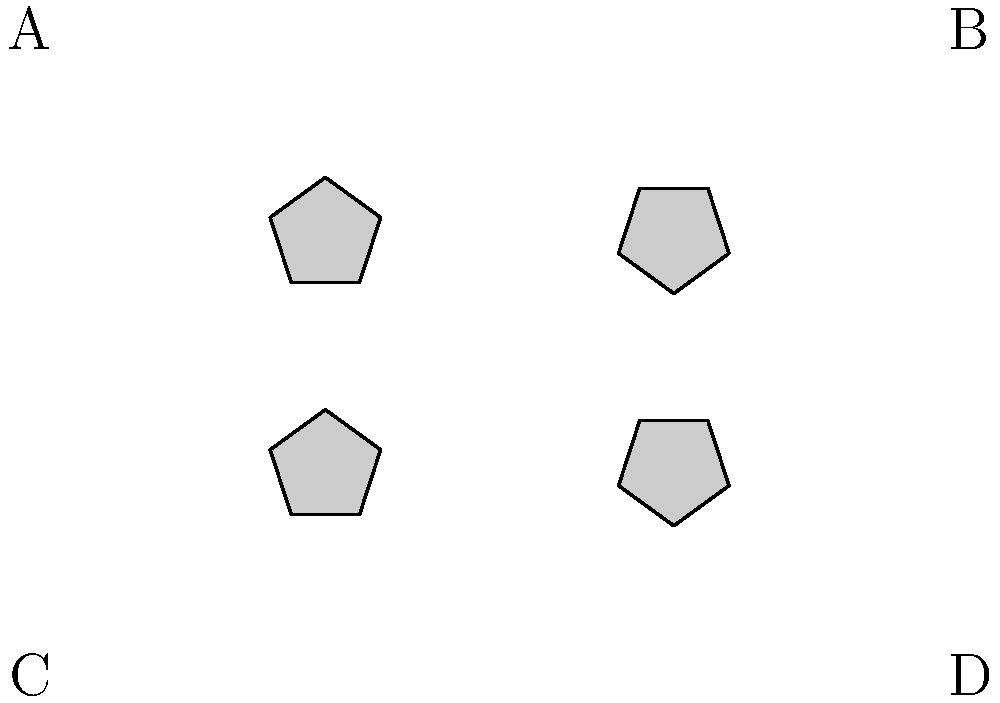Consider the four pentagons labeled A, B, C, and D. Which pair of pentagons are identical when one is rotated to match the other? To solve this problem, we need to mentally rotate each pentagon and compare it with the others. Let's analyze each pair step-by-step:

1. Compare A and B:
   - A is a regular pentagon in its standard orientation.
   - B appears to be rotated clockwise by 36° (one-tenth of a full rotation).
   - If we rotate A clockwise by 36°, it would match B.

2. Compare A and C:
   - C appears to be rotated clockwise by 72° (one-fifth of a full rotation).
   - If we rotate A clockwise by 72°, it would not match C.

3. Compare A and D:
   - D appears to be rotated counterclockwise by 36°.
   - If we rotate A counterclockwise by 36°, it would not match D.

4. Compare B and C:
   - B is rotated 36° clockwise from the standard orientation.
   - C is rotated 72° clockwise from the standard orientation.
   - The difference in rotation is 36°, so they do not match.

5. Compare B and D:
   - B is rotated 36° clockwise from the standard orientation.
   - D is rotated 36° counterclockwise from the standard orientation.
   - The total difference in rotation is 72°, so they do not match.

6. Compare C and D:
   - C is rotated 72° clockwise from the standard orientation.
   - D is rotated 36° counterclockwise from the standard orientation.
   - The total difference in rotation is 108°, so they do not match.

From this analysis, we can conclude that only pentagons A and B are identical when one is rotated to match the other.
Answer: A and B 